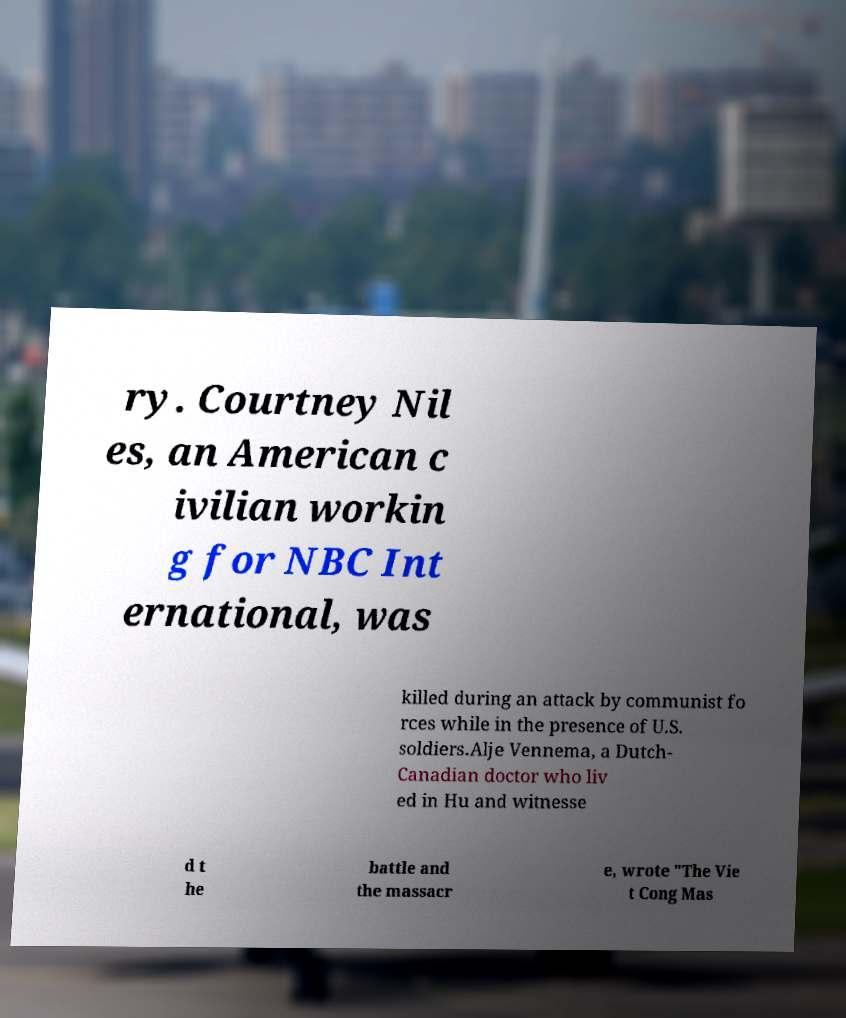Please identify and transcribe the text found in this image. ry. Courtney Nil es, an American c ivilian workin g for NBC Int ernational, was killed during an attack by communist fo rces while in the presence of U.S. soldiers.Alje Vennema, a Dutch- Canadian doctor who liv ed in Hu and witnesse d t he battle and the massacr e, wrote "The Vie t Cong Mas 